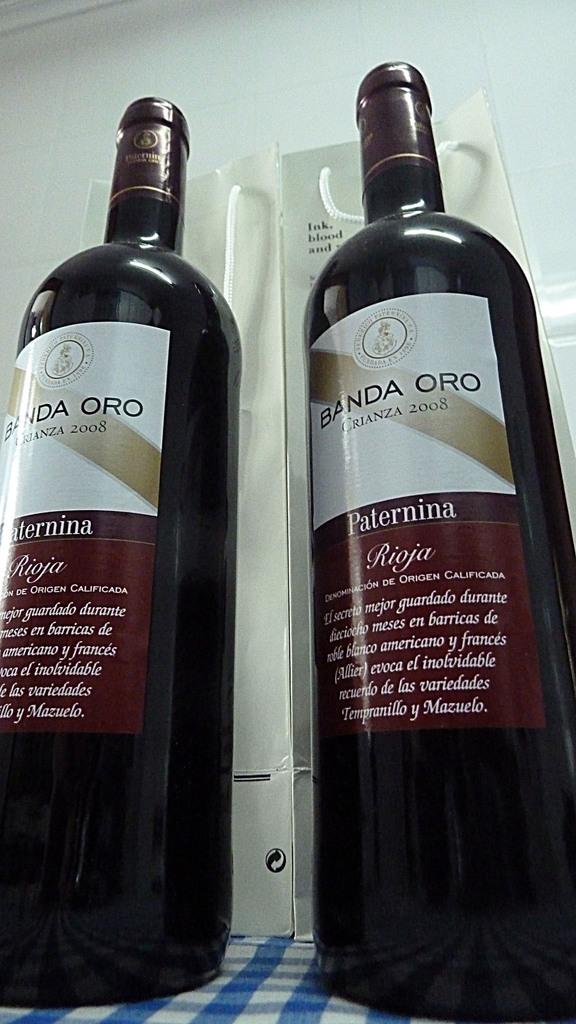What type of wine is this?
Keep it short and to the point. Rioja. What year was the wine bottled?
Ensure brevity in your answer.  2008. 